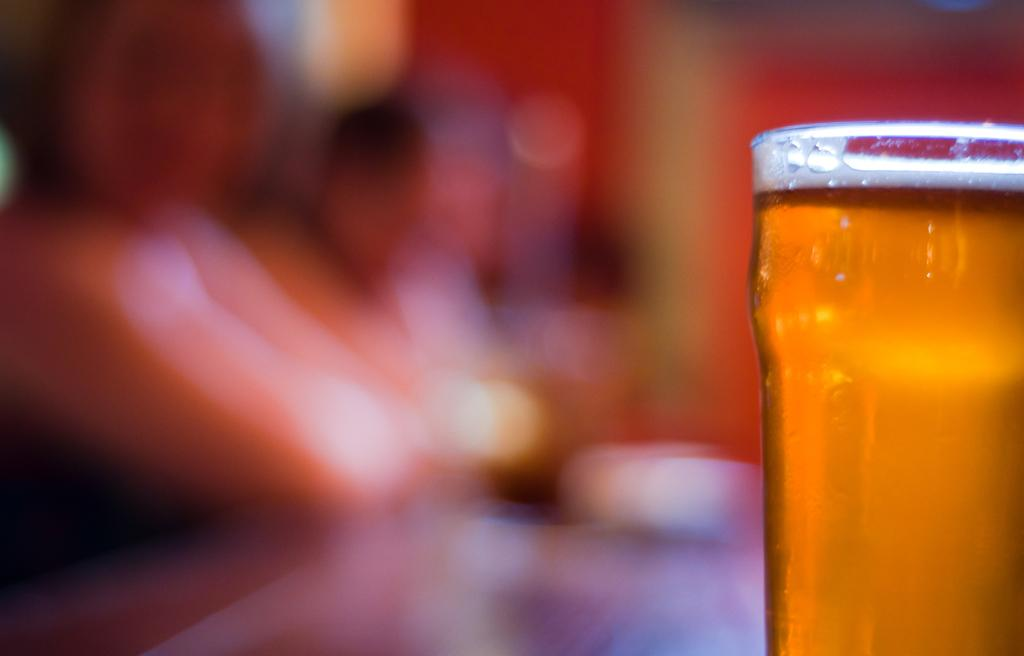What can be observed about the clarity of the image? The image is blurry. What object can be seen on the right side of the image? There is a glass with a drink on the right side of the image. What letter is being held by the hand in the image? There is no hand or letter present in the image; it only features. 